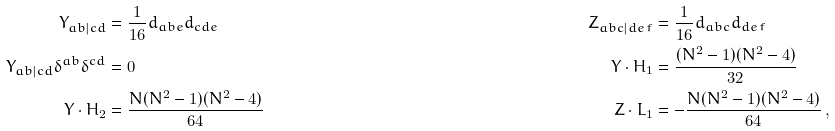Convert formula to latex. <formula><loc_0><loc_0><loc_500><loc_500>Y _ { a b | c d } & = \frac { 1 } { 1 6 } d _ { a b e } d _ { c d e } & Z _ { a b c | d e \, f } & = \frac { 1 } { 1 6 } d _ { a b c } d _ { d e \, f } \\ Y _ { a b | c d } \delta ^ { a b } \delta ^ { c d } & = 0 & Y \cdot H _ { 1 } & = \frac { ( N ^ { 2 } - 1 ) ( N ^ { 2 } - 4 ) } { 3 2 } \\ Y \cdot H _ { 2 } & = \frac { N ( N ^ { 2 } - 1 ) ( N ^ { 2 } - 4 ) } { 6 4 } & Z \cdot L _ { 1 } & = - \frac { N ( N ^ { 2 } - 1 ) ( N ^ { 2 } - 4 ) } { 6 4 } \, ,</formula> 